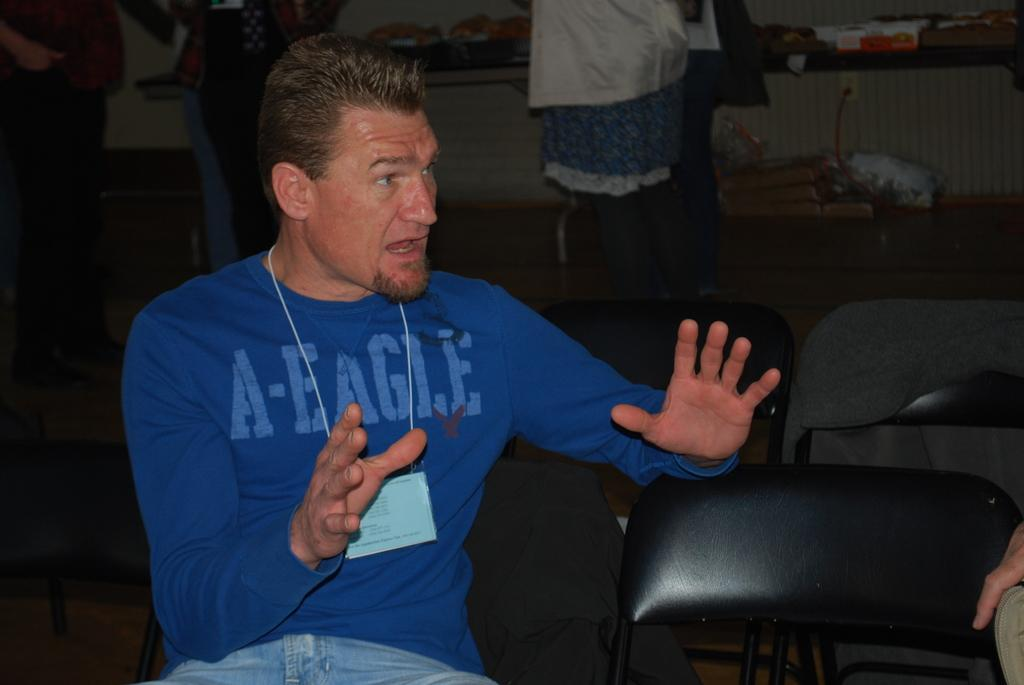What is the person in the image doing? The person is sitting in the image. What is the person wearing? The person is wearing a blue t-shirt. Are there any other people visible in the image? Yes, there are other people behind the person. What type of pen is the person using to make a payment in the image? There is no pen or payment activity present in the image; the person is simply sitting. 